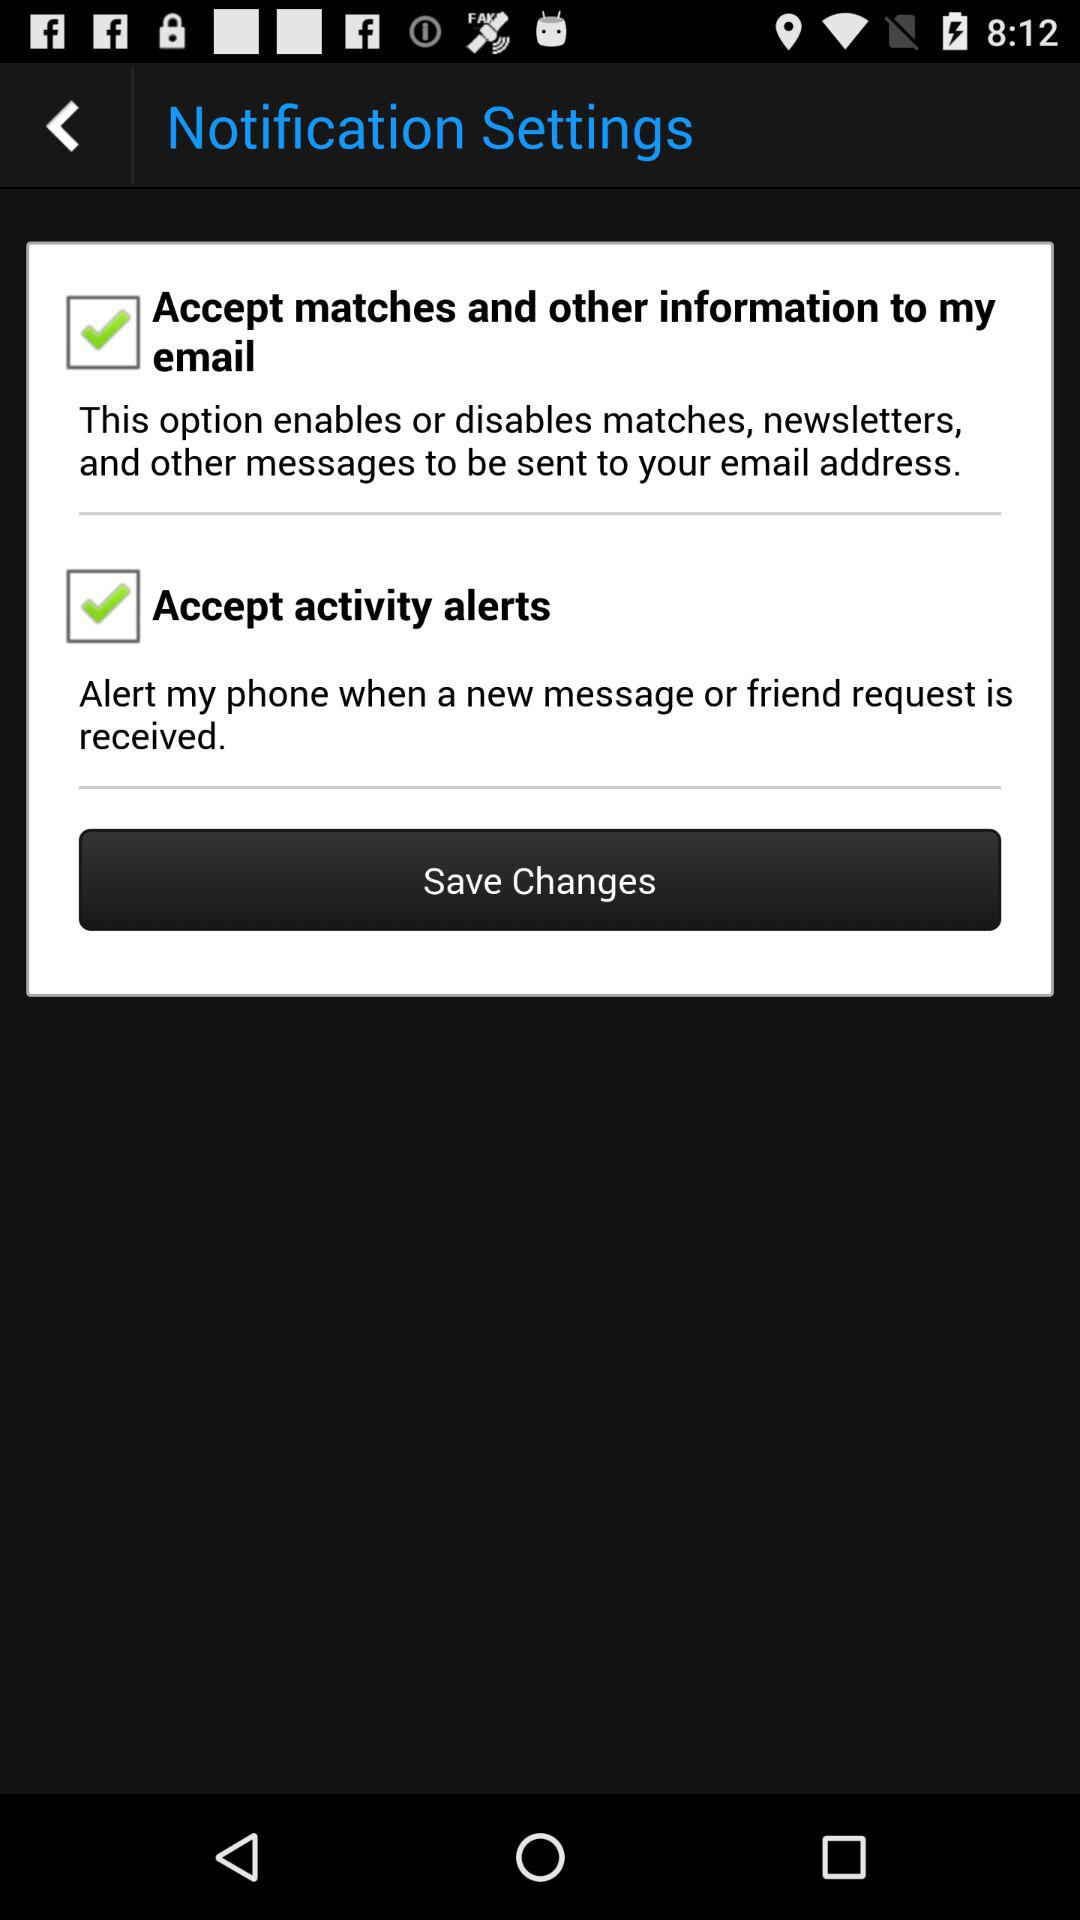How many checkboxes are there to enable or disable notifications?
Answer the question using a single word or phrase. 2 